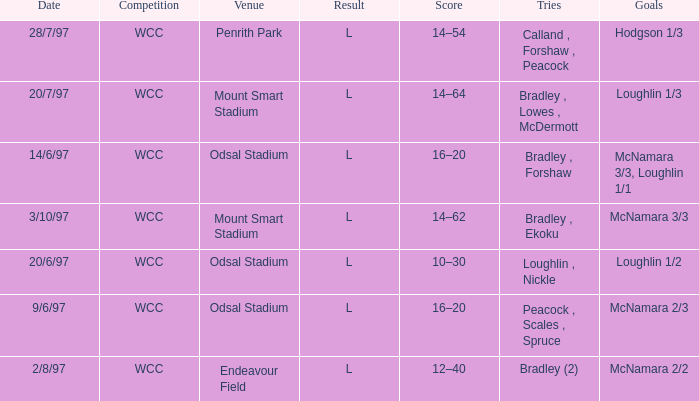Could you parse the entire table as a dict? {'header': ['Date', 'Competition', 'Venue', 'Result', 'Score', 'Tries', 'Goals'], 'rows': [['28/7/97', 'WCC', 'Penrith Park', 'L', '14–54', 'Calland , Forshaw , Peacock', 'Hodgson 1/3'], ['20/7/97', 'WCC', 'Mount Smart Stadium', 'L', '14–64', 'Bradley , Lowes , McDermott', 'Loughlin 1/3'], ['14/6/97', 'WCC', 'Odsal Stadium', 'L', '16–20', 'Bradley , Forshaw', 'McNamara 3/3, Loughlin 1/1'], ['3/10/97', 'WCC', 'Mount Smart Stadium', 'L', '14–62', 'Bradley , Ekoku', 'McNamara 3/3'], ['20/6/97', 'WCC', 'Odsal Stadium', 'L', '10–30', 'Loughlin , Nickle', 'Loughlin 1/2'], ['9/6/97', 'WCC', 'Odsal Stadium', 'L', '16–20', 'Peacock , Scales , Spruce', 'McNamara 2/3'], ['2/8/97', 'WCC', 'Endeavour Field', 'L', '12–40', 'Bradley (2)', 'McNamara 2/2']]} What were the goals on 3/10/97? McNamara 3/3. 